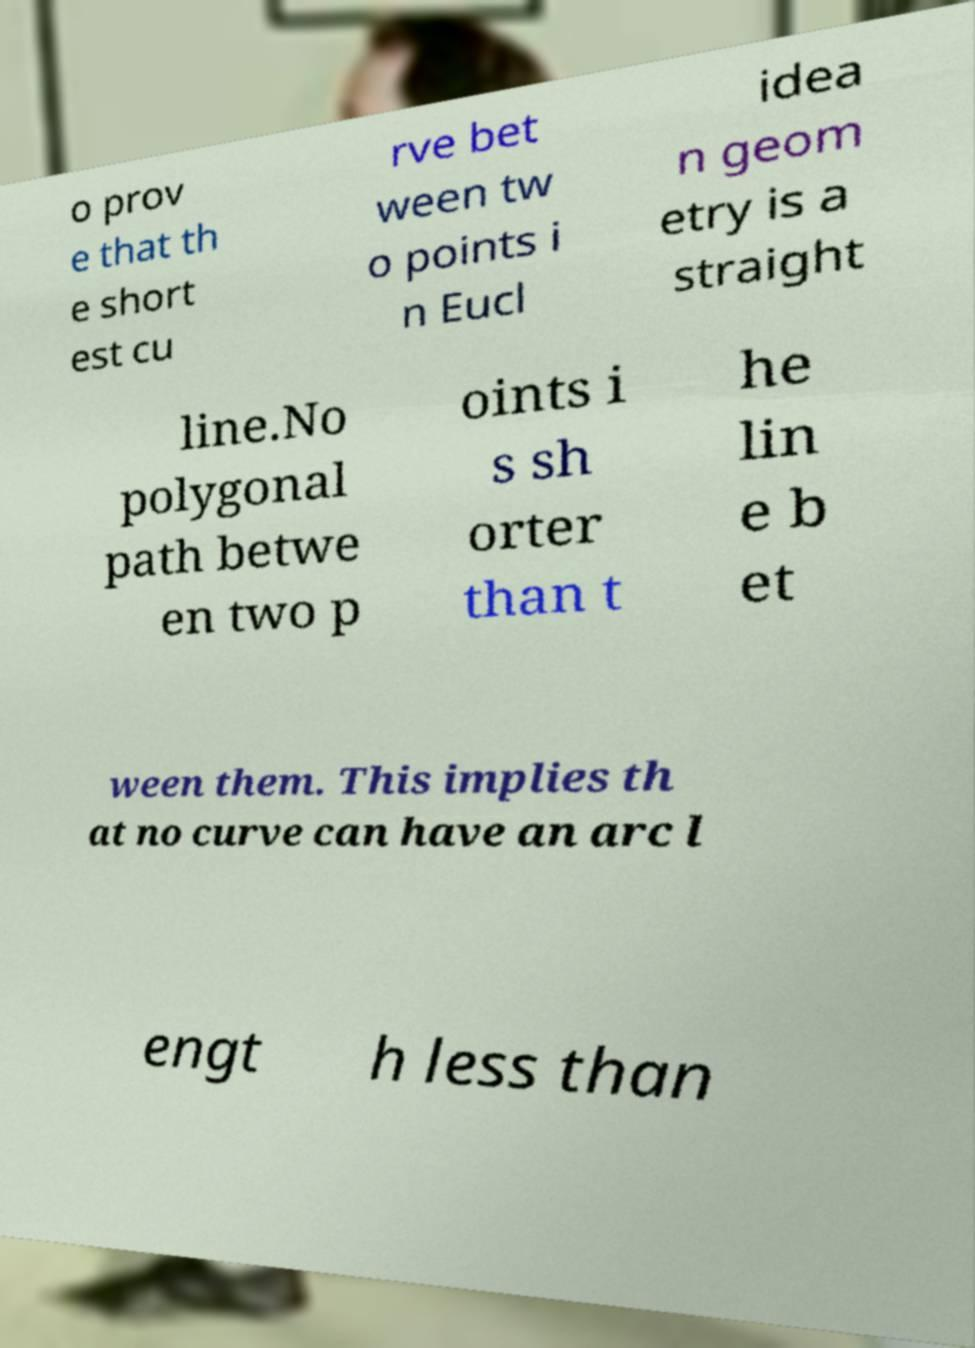Could you extract and type out the text from this image? o prov e that th e short est cu rve bet ween tw o points i n Eucl idea n geom etry is a straight line.No polygonal path betwe en two p oints i s sh orter than t he lin e b et ween them. This implies th at no curve can have an arc l engt h less than 